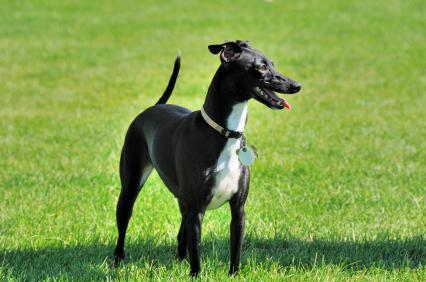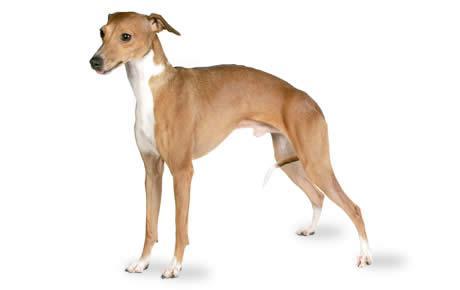The first image is the image on the left, the second image is the image on the right. Analyze the images presented: Is the assertion "The right image shows a hound standing on thick green grass." valid? Answer yes or no. No. 